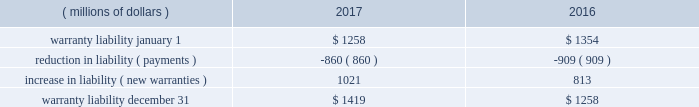2017 form 10-k | 115 and $ 1088 million , respectively , were primarily comprised of loans to dealers , and the spc 2019s liabilities of $ 1106 million and $ 1087 million , respectively , were primarily comprised of commercial paper .
The assets of the spc are not available to pay cat financial 2019s creditors .
Cat financial may be obligated to perform under the guarantee if the spc experiences losses .
No loss has been experienced or is anticipated under this loan purchase agreement .
Cat financial is party to agreements in the normal course of business with selected customers and caterpillar dealers in which they commit to provide a set dollar amount of financing on a pre- approved basis .
They also provide lines of credit to certain customers and caterpillar dealers , of which a portion remains unused as of the end of the period .
Commitments and lines of credit generally have fixed expiration dates or other termination clauses .
It has been cat financial 2019s experience that not all commitments and lines of credit will be used .
Management applies the same credit policies when making commitments and granting lines of credit as it does for any other financing .
Cat financial does not require collateral for these commitments/ lines , but if credit is extended , collateral may be required upon funding .
The amount of the unused commitments and lines of credit for dealers as of december 31 , 2017 and 2016 was $ 10993 million and $ 12775 million , respectively .
The amount of the unused commitments and lines of credit for customers as of december 31 , 2017 and 2016 was $ 3092 million and $ 3340 million , respectively .
Our product warranty liability is determined by applying historical claim rate experience to the current field population and dealer inventory .
Generally , historical claim rates are based on actual warranty experience for each product by machine model/engine size by customer or dealer location ( inside or outside north america ) .
Specific rates are developed for each product shipment month and are updated monthly based on actual warranty claim experience. .
22 .
Environmental and legal matters the company is regulated by federal , state and international environmental laws governing our use , transport and disposal of substances and control of emissions .
In addition to governing our manufacturing and other operations , these laws often impact the development of our products , including , but not limited to , required compliance with air emissions standards applicable to internal combustion engines .
We have made , and will continue to make , significant research and development and capital expenditures to comply with these emissions standards .
We are engaged in remedial activities at a number of locations , often with other companies , pursuant to federal and state laws .
When it is probable we will pay remedial costs at a site , and those costs can be reasonably estimated , the investigation , remediation , and operating and maintenance costs are accrued against our earnings .
Costs are accrued based on consideration of currently available data and information with respect to each individual site , including available technologies , current applicable laws and regulations , and prior remediation experience .
Where no amount within a range of estimates is more likely , we accrue the minimum .
Where multiple potentially responsible parties are involved , we consider our proportionate share of the probable costs .
In formulating the estimate of probable costs , we do not consider amounts expected to be recovered from insurance companies or others .
We reassess these accrued amounts on a quarterly basis .
The amount recorded for environmental remediation is not material and is included in accrued expenses .
We believe there is no more than a remote chance that a material amount for remedial activities at any individual site , or at all the sites in the aggregate , will be required .
On january 7 , 2015 , the company received a grand jury subpoena from the u.s .
District court for the central district of illinois .
The subpoena requests documents and information from the company relating to , among other things , financial information concerning u.s .
And non-u.s .
Caterpillar subsidiaries ( including undistributed profits of non-u.s .
Subsidiaries and the movement of cash among u.s .
And non-u.s .
Subsidiaries ) .
The company has received additional subpoenas relating to this investigation requesting additional documents and information relating to , among other things , the purchase and resale of replacement parts by caterpillar inc .
And non-u.s .
Caterpillar subsidiaries , dividend distributions of certain non-u.s .
Caterpillar subsidiaries , and caterpillar sarl and related structures .
On march 2-3 , 2017 , agents with the department of commerce , the federal deposit insurance corporation and the internal revenue service executed search and seizure warrants at three facilities of the company in the peoria , illinois area , including its former corporate headquarters .
The warrants identify , and agents seized , documents and information related to , among other things , the export of products from the united states , the movement of products between the united states and switzerland , the relationship between caterpillar inc .
And caterpillar sarl , and sales outside the united states .
It is the company 2019s understanding that the warrants , which concern both tax and export activities , are related to the ongoing grand jury investigation .
The company is continuing to cooperate with this investigation .
The company is unable to predict the outcome or reasonably estimate any potential loss ; however , we currently believe that this matter will not have a material adverse effect on the company 2019s consolidated results of operations , financial position or liquidity .
On march 20 , 2014 , brazil 2019s administrative council for economic defense ( cade ) published a technical opinion which named 18 companies and over 100 individuals as defendants , including two subsidiaries of caterpillar inc. , mge - equipamentos e servi e7os ferrovi e1rios ltda .
( mge ) and caterpillar brasil ltda .
The publication of the technical opinion opened cade 2019s official administrative investigation into allegations that the defendants participated in anticompetitive bid activity for the construction and maintenance of metro and train networks in brazil .
While companies cannot be .
What is the 2017 growth rate in the amount of the unused commitments and lines of credit for dealers? 
Computations: ((10993 - 12775) / 12775)
Answer: -0.13949. 